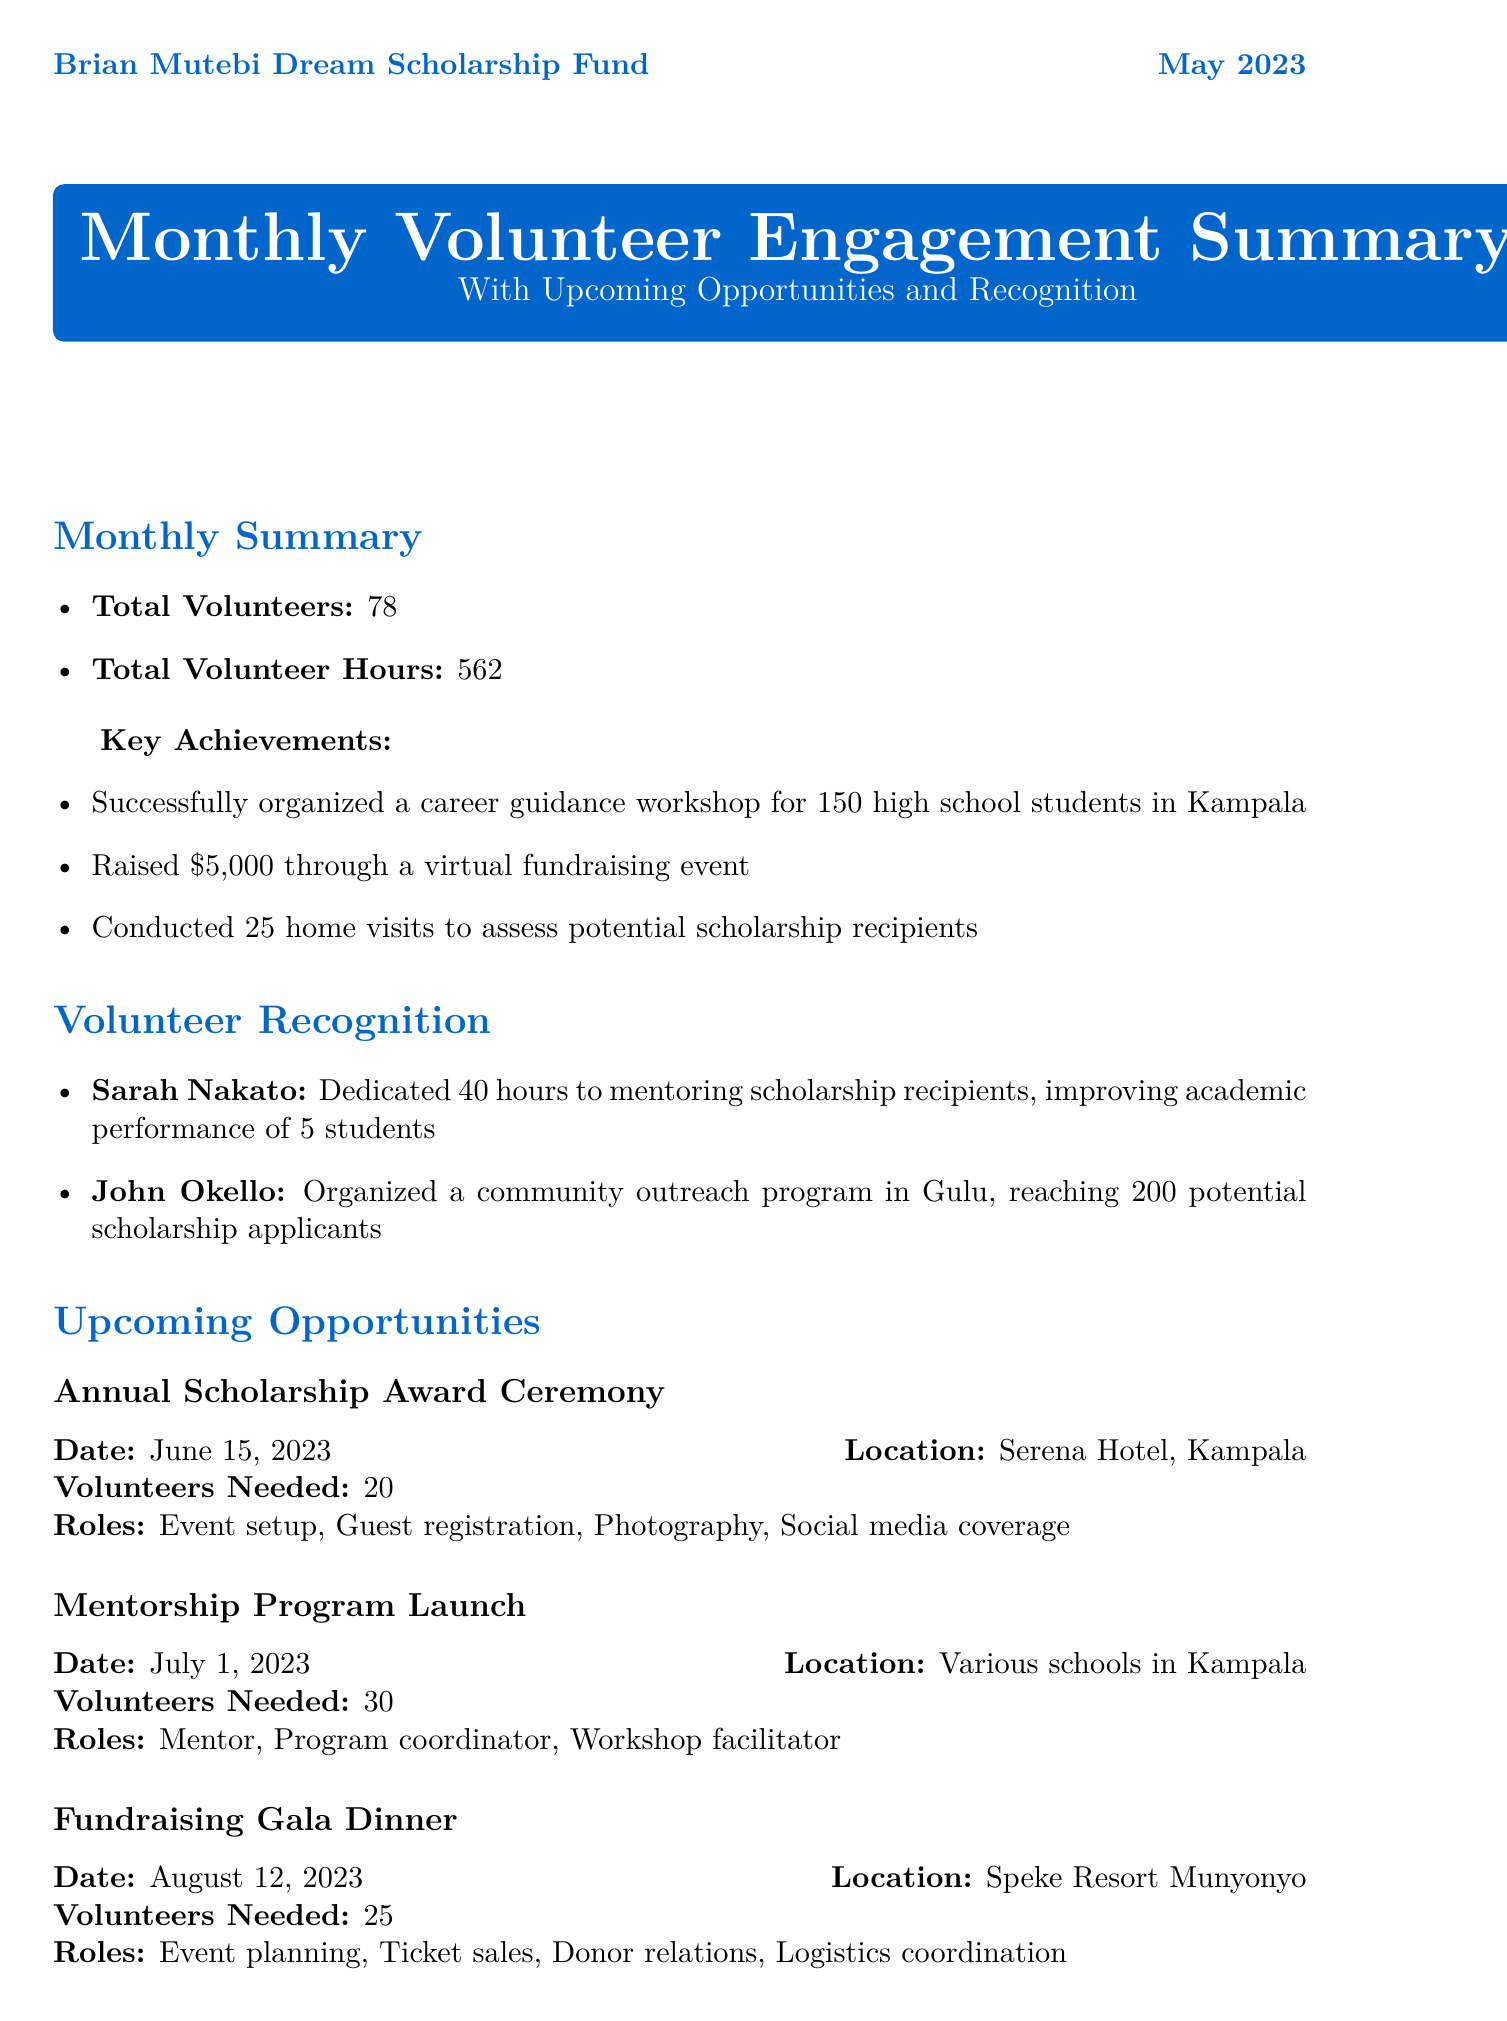What is the total number of volunteers? The total number of volunteers is listed as part of the monthly summary section.
Answer: 78 What was the total volunteer hours for May 2023? The total volunteer hours is mentioned in the monthly summary section of the report.
Answer: 562 Who is recognized for dedicating 40 hours to mentoring? This individual’s recognition includes their name and contribution, which can be found in the volunteer recognition section.
Answer: Sarah Nakato What is the impact of John Okello's community outreach program? The impact of this program is described in the volunteer recognition section, specifying who he reached.
Answer: Reached 200 potential scholarship applicants When is the Annual Scholarship Award Ceremony? The date for this event is provided in the upcoming opportunities section, which lists events chronologically.
Answer: June 15, 2023 What will happen on July 1, 2023? This date is associated with an upcoming event that involves volunteers, mentioned in the upcoming opportunities section.
Answer: Mentorship Program Launch How many volunteers are needed for the Fundraising Gala Dinner? The number of volunteers required for this upcoming event is specified clearly in the respective section.
Answer: 25 What is the target number of students for the School Supply Drive? The target for the ongoing project is mentioned, reflecting the goal of the initiative outlined in the report.
Answer: 100 students What role does Grace Achieng fulfill in the organization? This information is found in the volunteer testimonial section, where she describes her roles.
Answer: Mentor and Fundraising Volunteer 